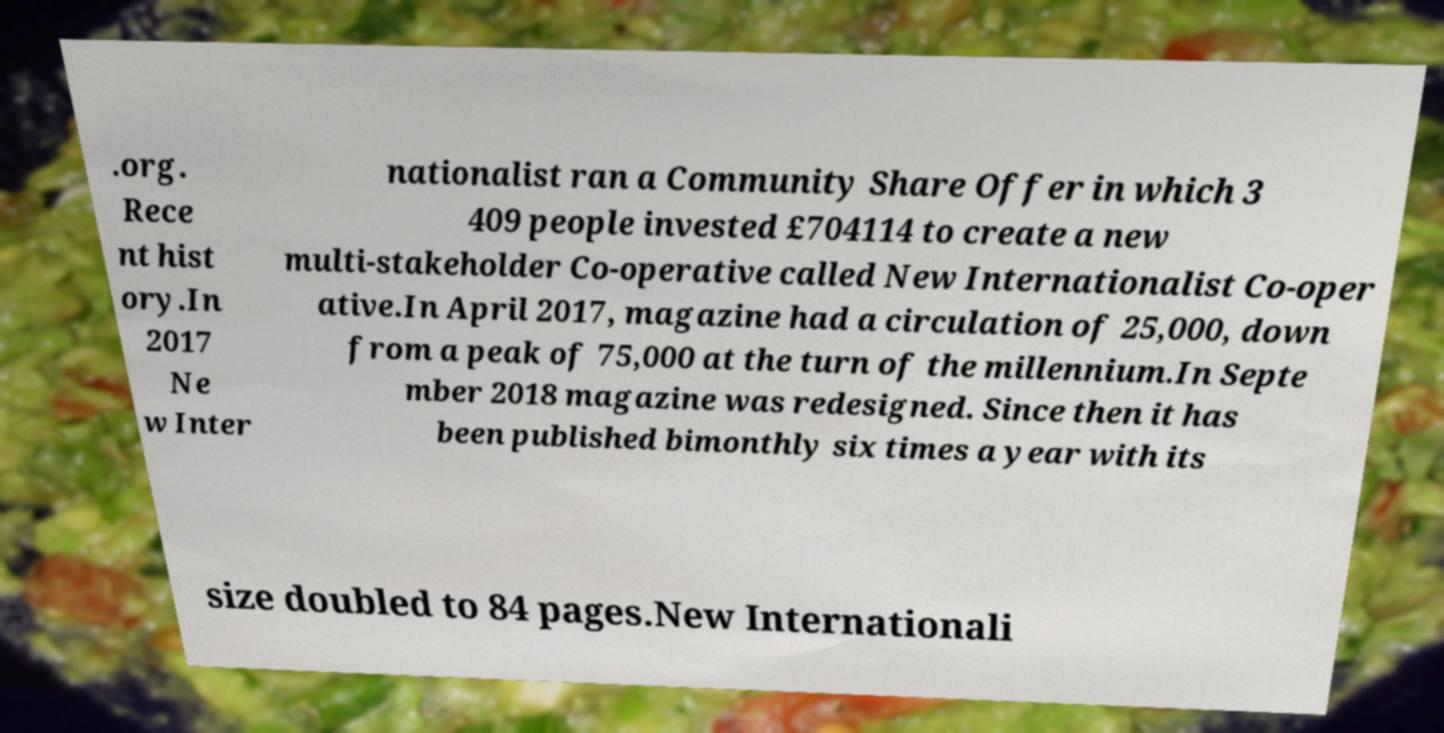Can you read and provide the text displayed in the image?This photo seems to have some interesting text. Can you extract and type it out for me? .org. Rece nt hist ory.In 2017 Ne w Inter nationalist ran a Community Share Offer in which 3 409 people invested £704114 to create a new multi-stakeholder Co-operative called New Internationalist Co-oper ative.In April 2017, magazine had a circulation of 25,000, down from a peak of 75,000 at the turn of the millennium.In Septe mber 2018 magazine was redesigned. Since then it has been published bimonthly six times a year with its size doubled to 84 pages.New Internationali 